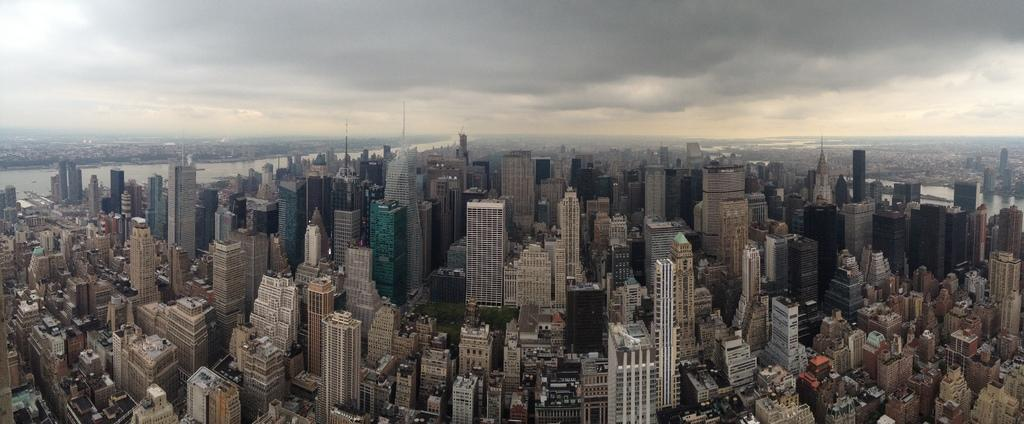What type of location is shown in the image? The image depicts a city. What can be seen in the cityscape? There are many buildings in the image. What are the poles used for in the image? The purpose of the poles is not specified, but they could be for streetlights, traffic signals, or other urban infrastructure. What is visible in the background of the image? There is water visible in the background on both the left and right sides. What is the condition of the sky in the image? There are clouds in the sky. Where is the monkey sitting in the image? There is no monkey present in the image. What class is being taught in the image? There is no indication of a class or any educational activity in the image. 